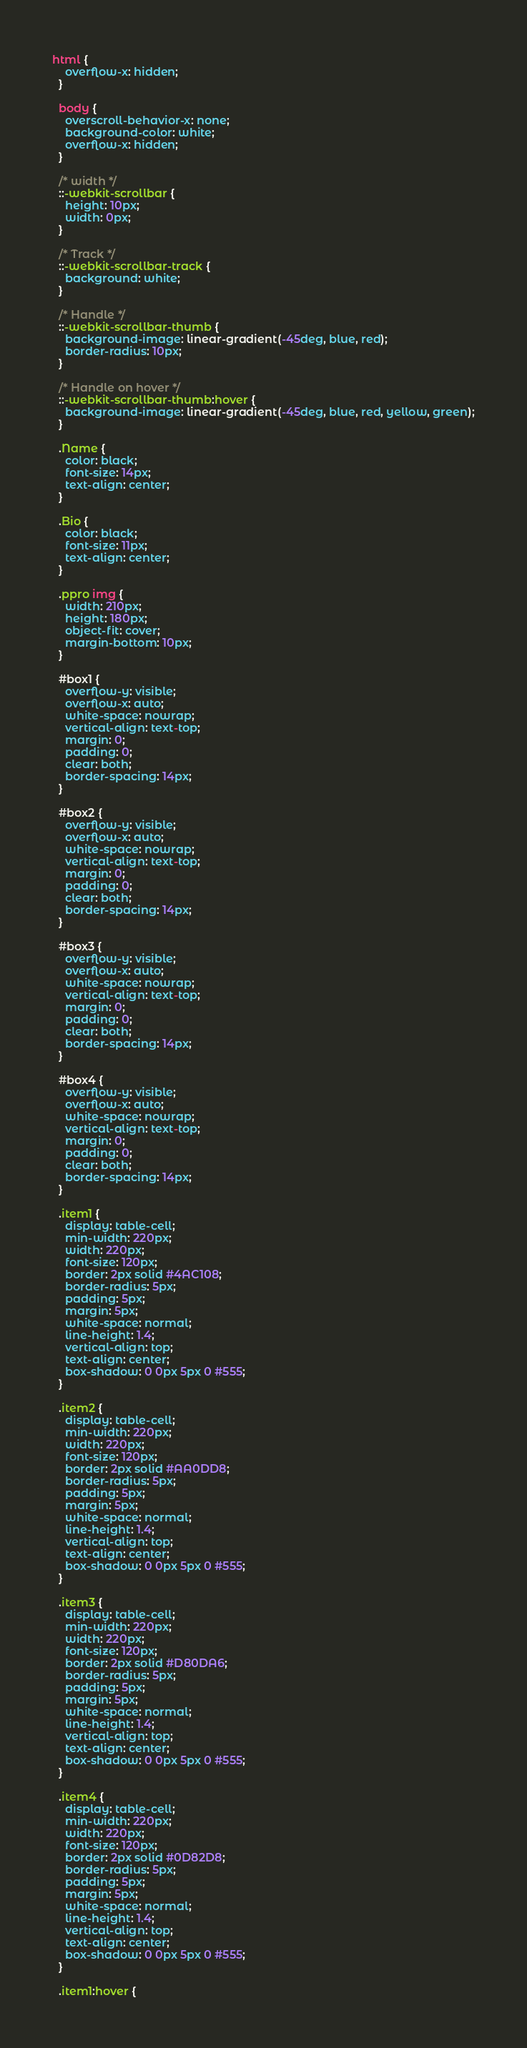Convert code to text. <code><loc_0><loc_0><loc_500><loc_500><_CSS_>html {
    overflow-x: hidden;
  }

  body {
    overscroll-behavior-x: none;
    background-color: white;
    overflow-x: hidden;
  }
 
  /* width */
  ::-webkit-scrollbar {
    height: 10px;
    width: 0px;
  }

  /* Track */
  ::-webkit-scrollbar-track {
    background: white;
  }

  /* Handle */
  ::-webkit-scrollbar-thumb {
    background-image: linear-gradient(-45deg, blue, red);
    border-radius: 10px;
  }

  /* Handle on hover */
  ::-webkit-scrollbar-thumb:hover {
    background-image: linear-gradient(-45deg, blue, red, yellow, green);
  }

  .Name {
    color: black;
    font-size: 14px;
    text-align: center;
  }

  .Bio {
    color: black;
    font-size: 11px;
    text-align: center;
  }

  .ppro img {
    width: 210px;
    height: 180px;
    object-fit: cover;
    margin-bottom: 10px;
  }

  #box1 {
    overflow-y: visible;
    overflow-x: auto;
    white-space: nowrap;
    vertical-align: text-top;
    margin: 0;
    padding: 0;
    clear: both;
    border-spacing: 14px;
  }

  #box2 {
    overflow-y: visible;
    overflow-x: auto;
    white-space: nowrap;
    vertical-align: text-top;
    margin: 0;
    padding: 0;
    clear: both;
    border-spacing: 14px;
  }

  #box3 {
    overflow-y: visible;
    overflow-x: auto;
    white-space: nowrap;
    vertical-align: text-top;
    margin: 0;
    padding: 0;
    clear: both;
    border-spacing: 14px;
  }

  #box4 {
    overflow-y: visible;
    overflow-x: auto;
    white-space: nowrap;
    vertical-align: text-top;
    margin: 0;
    padding: 0;
    clear: both;
    border-spacing: 14px;
  }

  .item1 {
    display: table-cell;
    min-width: 220px;
    width: 220px;
    font-size: 120px;
    border: 2px solid #4AC108;
    border-radius: 5px;
    padding: 5px;
    margin: 5px;
    white-space: normal;
    line-height: 1.4;
    vertical-align: top;
    text-align: center;
    box-shadow: 0 0px 5px 0 #555;
  }

  .item2 {
    display: table-cell;
    min-width: 220px;
    width: 220px;
    font-size: 120px;
    border: 2px solid #AA0DD8;
    border-radius: 5px;
    padding: 5px;
    margin: 5px;
    white-space: normal;
    line-height: 1.4;
    vertical-align: top;
    text-align: center;
    box-shadow: 0 0px 5px 0 #555;
  }

  .item3 {
    display: table-cell;
    min-width: 220px;
    width: 220px;
    font-size: 120px;
    border: 2px solid #D80DA6;
    border-radius: 5px;
    padding: 5px;
    margin: 5px;
    white-space: normal;
    line-height: 1.4;
    vertical-align: top;
    text-align: center;
    box-shadow: 0 0px 5px 0 #555;
  }

  .item4 {
    display: table-cell;
    min-width: 220px;
    width: 220px;
    font-size: 120px;
    border: 2px solid #0D82D8;
    border-radius: 5px;
    padding: 5px;
    margin: 5px;
    white-space: normal;
    line-height: 1.4;
    vertical-align: top;
    text-align: center;
    box-shadow: 0 0px 5px 0 #555;
  }

  .item1:hover {</code> 